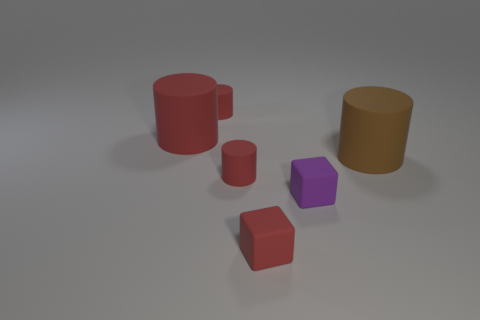Subtract all red cylinders. How many cylinders are left? 1 Subtract all red cylinders. How many cylinders are left? 1 Subtract all brown blocks. Subtract all green cylinders. How many blocks are left? 2 Subtract all purple blocks. How many blue cylinders are left? 0 Subtract all small red rubber objects. Subtract all brown objects. How many objects are left? 2 Add 4 small matte things. How many small matte things are left? 8 Add 3 small purple cubes. How many small purple cubes exist? 4 Add 1 red cubes. How many objects exist? 7 Subtract 0 blue cylinders. How many objects are left? 6 Subtract all blocks. How many objects are left? 4 